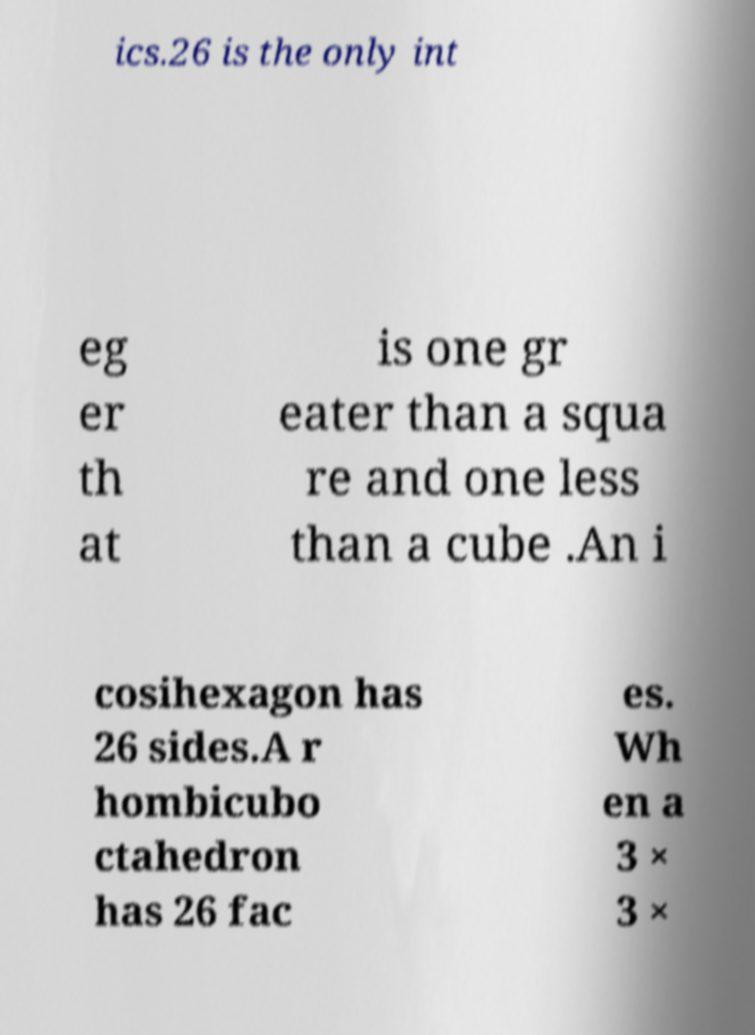Could you extract and type out the text from this image? ics.26 is the only int eg er th at is one gr eater than a squa re and one less than a cube .An i cosihexagon has 26 sides.A r hombicubo ctahedron has 26 fac es. Wh en a 3 × 3 × 